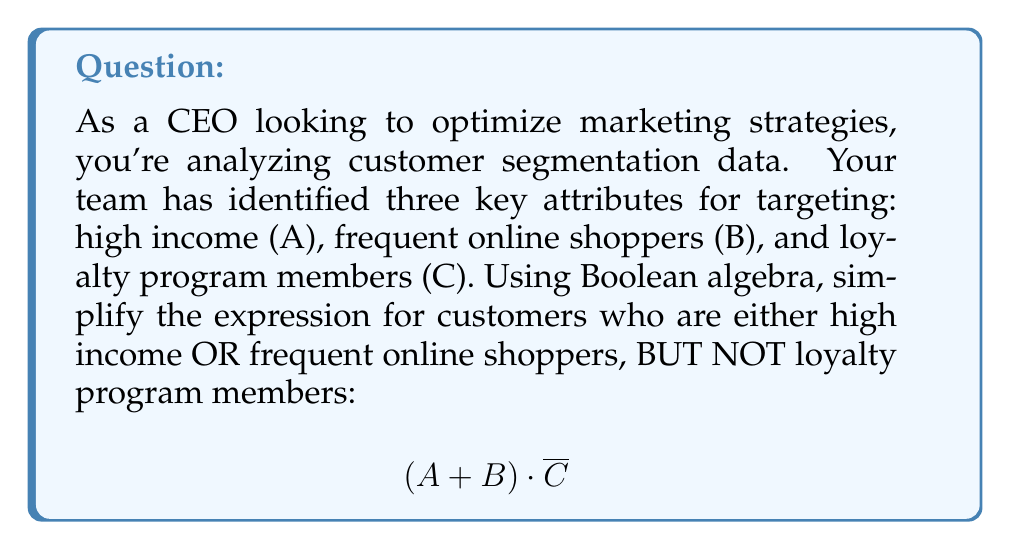Can you solve this math problem? Let's simplify this expression step-by-step using Boolean algebraic laws:

1) First, we start with the given expression:
   $$(A + B) \cdot \overline{C}$$

2) We can apply the distributive law to expand this expression:
   $$A \cdot \overline{C} + B \cdot \overline{C}$$

3) This expression is already in its simplest form. It represents:
   - Customers who are high income (A) AND not loyalty program members ($\overline{C}$)
   - OR
   - Customers who are frequent online shoppers (B) AND not loyalty program members ($\overline{C}$)

4) In terms of set theory, this would be the union of two intersections:
   $(A \cap \overline{C}) \cup (B \cap \overline{C})$

This simplified form allows for more efficient targeting of customer segments, focusing on high-income non-members and frequent online shopper non-members separately.
Answer: $$A \cdot \overline{C} + B \cdot \overline{C}$$ 